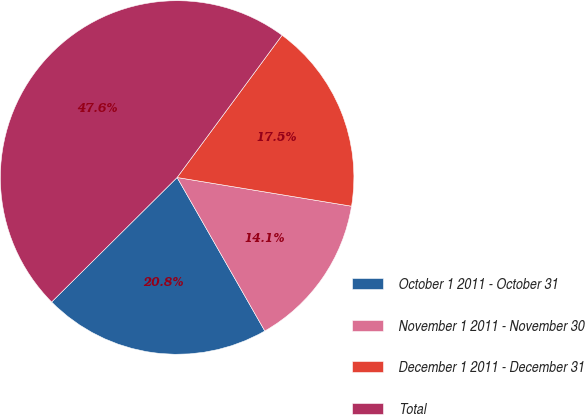<chart> <loc_0><loc_0><loc_500><loc_500><pie_chart><fcel>October 1 2011 - October 31<fcel>November 1 2011 - November 30<fcel>December 1 2011 - December 31<fcel>Total<nl><fcel>20.82%<fcel>14.14%<fcel>17.48%<fcel>47.55%<nl></chart> 